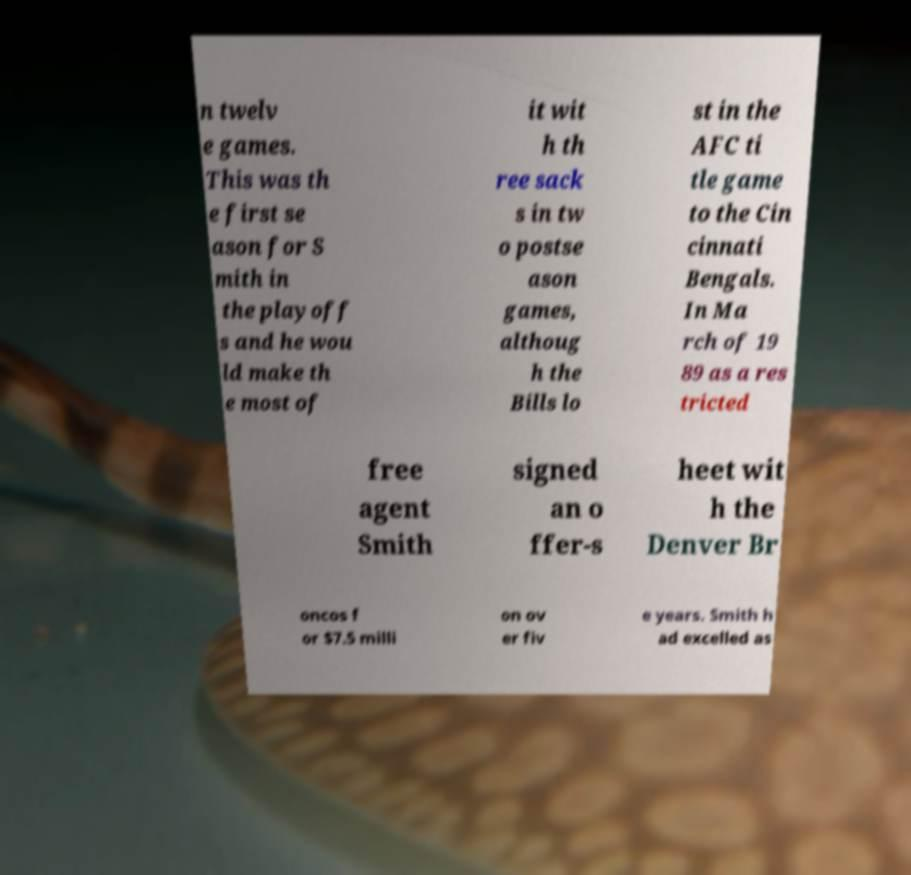Can you accurately transcribe the text from the provided image for me? n twelv e games. This was th e first se ason for S mith in the playoff s and he wou ld make th e most of it wit h th ree sack s in tw o postse ason games, althoug h the Bills lo st in the AFC ti tle game to the Cin cinnati Bengals. In Ma rch of 19 89 as a res tricted free agent Smith signed an o ffer-s heet wit h the Denver Br oncos f or $7.5 milli on ov er fiv e years. Smith h ad excelled as 